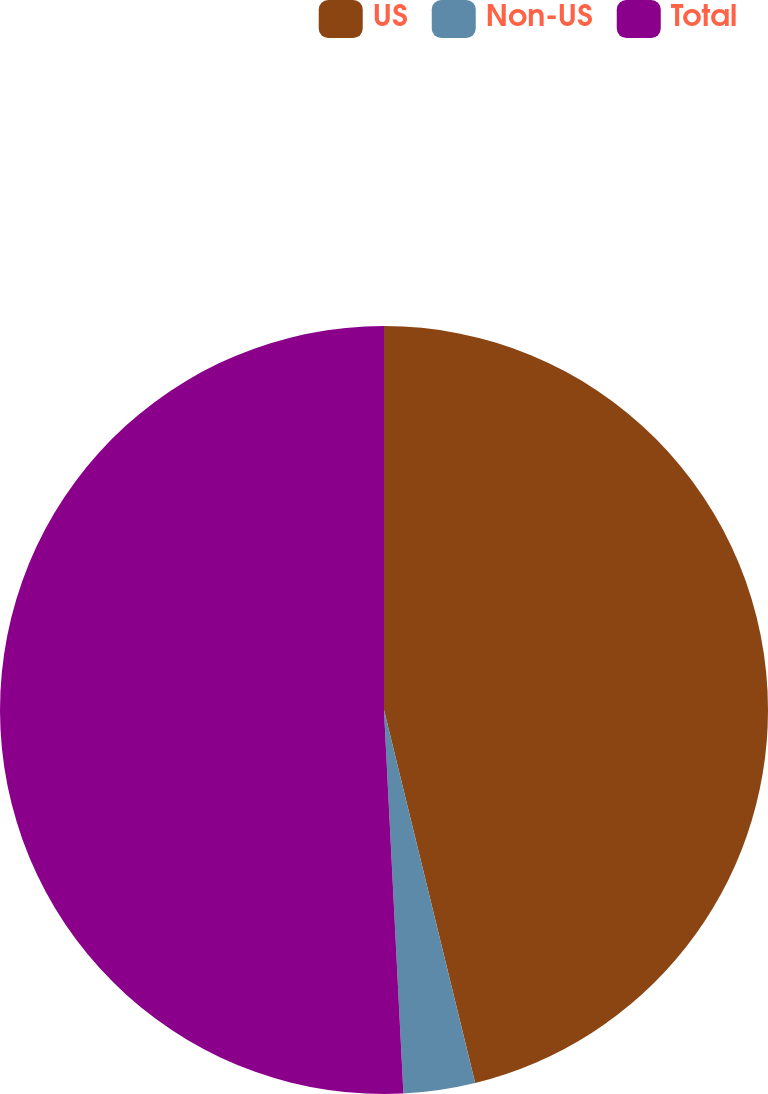<chart> <loc_0><loc_0><loc_500><loc_500><pie_chart><fcel>US<fcel>Non-US<fcel>Total<nl><fcel>46.19%<fcel>3.01%<fcel>50.81%<nl></chart> 